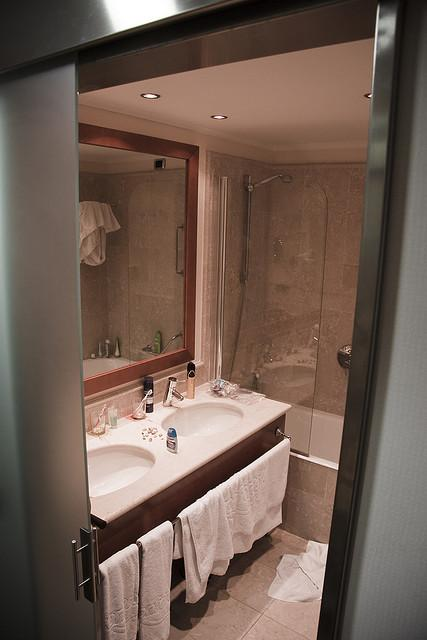How many people probably use this room? two 